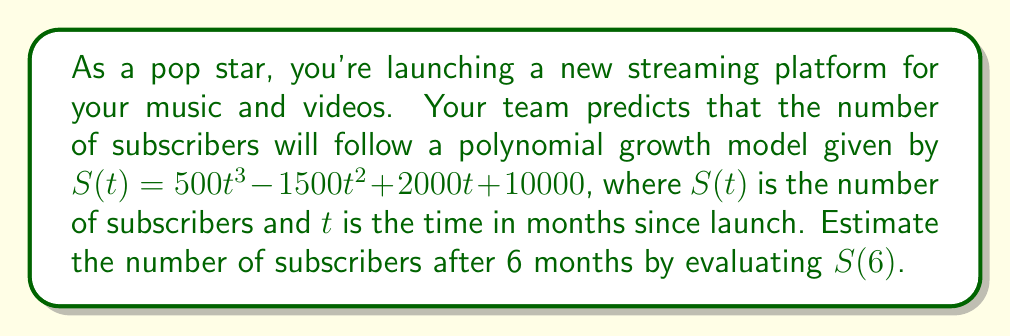Provide a solution to this math problem. To estimate the number of subscribers after 6 months, we need to evaluate the polynomial $S(t)$ at $t = 6$. Let's break this down step-by-step:

1) The given polynomial is:
   $S(t) = 500t^3 - 1500t^2 + 2000t + 10000$

2) We need to calculate $S(6)$, so we substitute $t = 6$ into the equation:
   $S(6) = 500(6)^3 - 1500(6)^2 + 2000(6) + 10000$

3) Let's evaluate each term:
   - $500(6)^3 = 500 \times 216 = 108,000$
   - $-1500(6)^2 = -1500 \times 36 = -54,000$
   - $2000(6) = 12,000$
   - The constant term remains $10,000$

4) Now, we add all these terms:
   $S(6) = 108,000 - 54,000 + 12,000 + 10,000$

5) Simplifying:
   $S(6) = 76,000$

Therefore, after 6 months, the estimated number of subscribers is 76,000.
Answer: 76,000 subscribers 